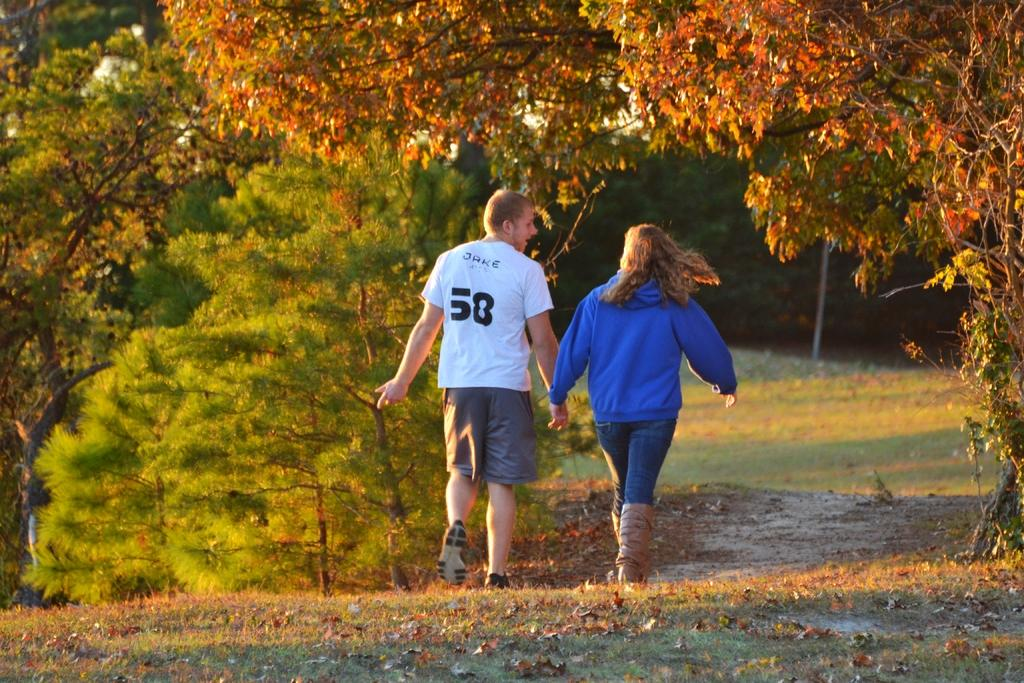What can be seen in the background of the image? There are trees in the background of the image. What object is visible in the image besides the trees? There is a pole visible in the image. How many people are present in the image? There is a woman and a man in the image. What are the woman and the man doing in the image? The woman and the man are holding hands and walking on the ground. What type of vegetable is being read by the woman in the image? There is no vegetable present in the image, nor is anyone reading a book. How quiet is the environment in the image? The provided facts do not give any information about the noise level in the image, so it cannot be determined. 